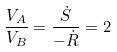<formula> <loc_0><loc_0><loc_500><loc_500>\frac { V _ { A } } { V _ { B } } = \frac { \dot { S } } { - \dot { R } } = 2</formula> 